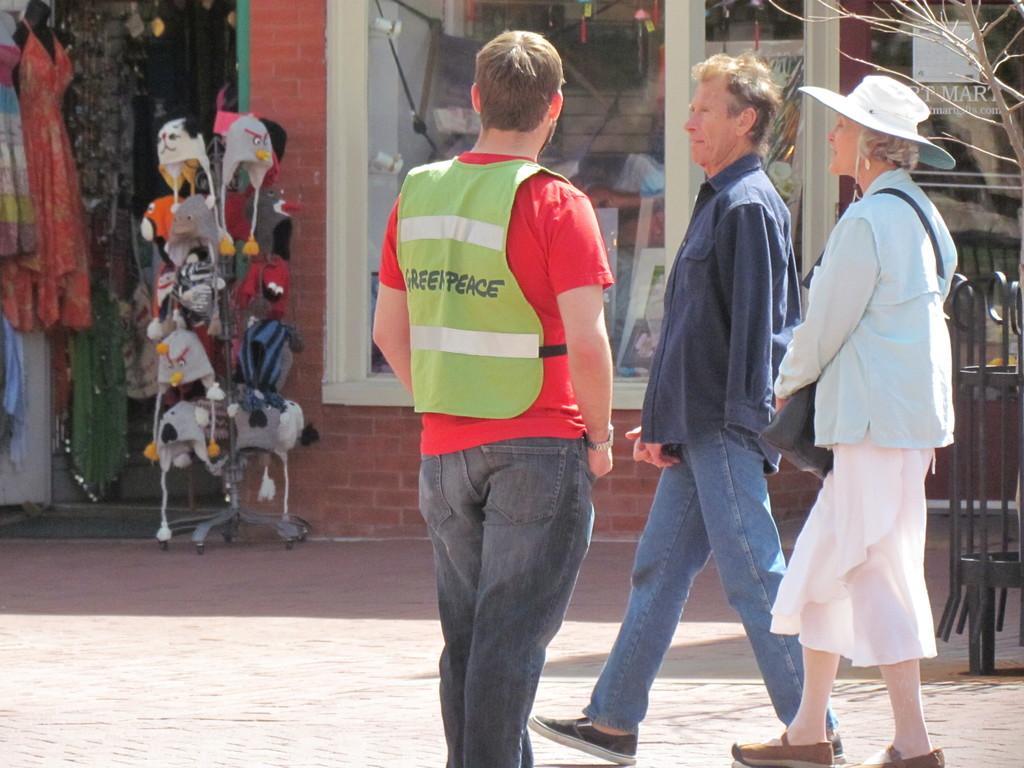Could you give a brief overview of what you see in this image? This is an outside view. In the foreground, I can see a man wearing red color t-shirt, green color jacket and standing. On the right side I can see a man and a woman are walking on the road towards the left side. At the back of these people there is a metal stand. In the background there is a wall and window. On the left side I can see some clothes and caps are hanging to a metal rod. 